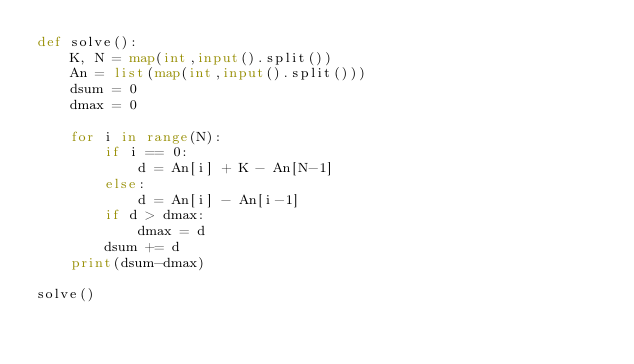<code> <loc_0><loc_0><loc_500><loc_500><_Python_>def solve():
    K, N = map(int,input().split())
    An = list(map(int,input().split()))
    dsum = 0
    dmax = 0

    for i in range(N):
        if i == 0:
            d = An[i] + K - An[N-1]
        else:
            d = An[i] - An[i-1]
        if d > dmax:
            dmax = d
        dsum += d
    print(dsum-dmax)

solve()
</code> 